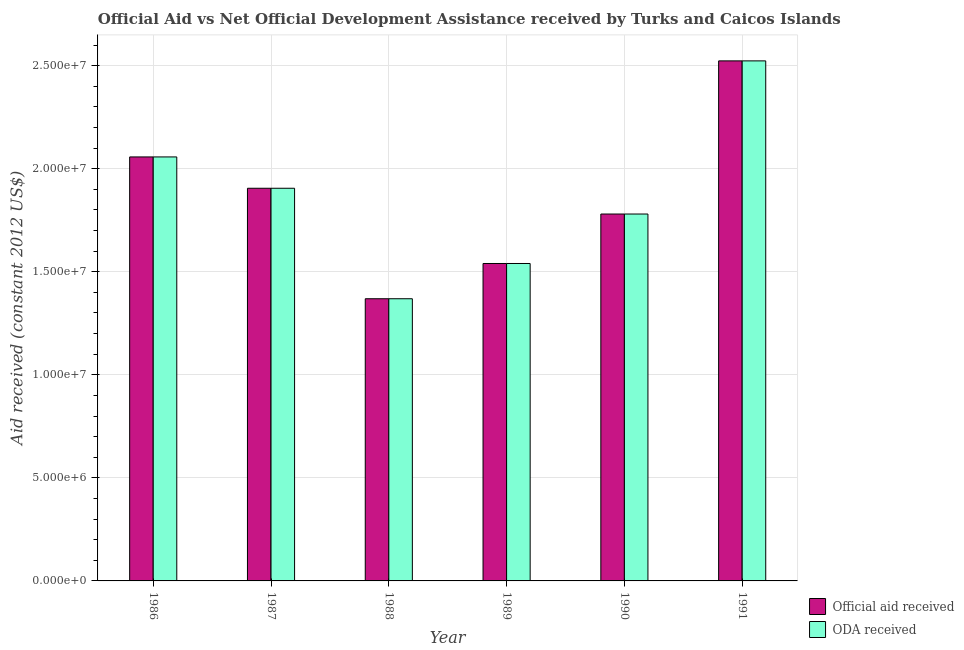Are the number of bars per tick equal to the number of legend labels?
Provide a short and direct response. Yes. How many bars are there on the 1st tick from the left?
Make the answer very short. 2. What is the oda received in 1991?
Provide a succinct answer. 2.52e+07. Across all years, what is the maximum oda received?
Keep it short and to the point. 2.52e+07. Across all years, what is the minimum oda received?
Your response must be concise. 1.37e+07. In which year was the oda received maximum?
Keep it short and to the point. 1991. In which year was the official aid received minimum?
Your answer should be compact. 1988. What is the total official aid received in the graph?
Offer a terse response. 1.12e+08. What is the difference between the official aid received in 1987 and that in 1988?
Offer a very short reply. 5.36e+06. What is the difference between the oda received in 1990 and the official aid received in 1989?
Your answer should be compact. 2.40e+06. What is the average official aid received per year?
Provide a succinct answer. 1.86e+07. In the year 1987, what is the difference between the oda received and official aid received?
Make the answer very short. 0. In how many years, is the official aid received greater than 18000000 US$?
Make the answer very short. 3. What is the ratio of the oda received in 1989 to that in 1990?
Ensure brevity in your answer.  0.87. Is the difference between the oda received in 1989 and 1991 greater than the difference between the official aid received in 1989 and 1991?
Make the answer very short. No. What is the difference between the highest and the second highest official aid received?
Ensure brevity in your answer.  4.66e+06. What is the difference between the highest and the lowest official aid received?
Provide a short and direct response. 1.15e+07. What does the 1st bar from the left in 1990 represents?
Ensure brevity in your answer.  Official aid received. What does the 1st bar from the right in 1989 represents?
Provide a short and direct response. ODA received. How many bars are there?
Your answer should be very brief. 12. Are all the bars in the graph horizontal?
Give a very brief answer. No. Are the values on the major ticks of Y-axis written in scientific E-notation?
Provide a succinct answer. Yes. Does the graph contain any zero values?
Your response must be concise. No. What is the title of the graph?
Provide a succinct answer. Official Aid vs Net Official Development Assistance received by Turks and Caicos Islands . What is the label or title of the Y-axis?
Your answer should be very brief. Aid received (constant 2012 US$). What is the Aid received (constant 2012 US$) in Official aid received in 1986?
Your answer should be compact. 2.06e+07. What is the Aid received (constant 2012 US$) of ODA received in 1986?
Provide a succinct answer. 2.06e+07. What is the Aid received (constant 2012 US$) in Official aid received in 1987?
Your response must be concise. 1.90e+07. What is the Aid received (constant 2012 US$) of ODA received in 1987?
Provide a succinct answer. 1.90e+07. What is the Aid received (constant 2012 US$) in Official aid received in 1988?
Your answer should be compact. 1.37e+07. What is the Aid received (constant 2012 US$) of ODA received in 1988?
Ensure brevity in your answer.  1.37e+07. What is the Aid received (constant 2012 US$) of Official aid received in 1989?
Give a very brief answer. 1.54e+07. What is the Aid received (constant 2012 US$) in ODA received in 1989?
Your answer should be compact. 1.54e+07. What is the Aid received (constant 2012 US$) of Official aid received in 1990?
Make the answer very short. 1.78e+07. What is the Aid received (constant 2012 US$) in ODA received in 1990?
Offer a terse response. 1.78e+07. What is the Aid received (constant 2012 US$) of Official aid received in 1991?
Your response must be concise. 2.52e+07. What is the Aid received (constant 2012 US$) in ODA received in 1991?
Provide a short and direct response. 2.52e+07. Across all years, what is the maximum Aid received (constant 2012 US$) of Official aid received?
Offer a terse response. 2.52e+07. Across all years, what is the maximum Aid received (constant 2012 US$) of ODA received?
Your response must be concise. 2.52e+07. Across all years, what is the minimum Aid received (constant 2012 US$) in Official aid received?
Your answer should be compact. 1.37e+07. Across all years, what is the minimum Aid received (constant 2012 US$) in ODA received?
Your answer should be compact. 1.37e+07. What is the total Aid received (constant 2012 US$) of Official aid received in the graph?
Offer a very short reply. 1.12e+08. What is the total Aid received (constant 2012 US$) in ODA received in the graph?
Ensure brevity in your answer.  1.12e+08. What is the difference between the Aid received (constant 2012 US$) in Official aid received in 1986 and that in 1987?
Offer a very short reply. 1.52e+06. What is the difference between the Aid received (constant 2012 US$) of ODA received in 1986 and that in 1987?
Offer a very short reply. 1.52e+06. What is the difference between the Aid received (constant 2012 US$) of Official aid received in 1986 and that in 1988?
Your answer should be compact. 6.88e+06. What is the difference between the Aid received (constant 2012 US$) of ODA received in 1986 and that in 1988?
Give a very brief answer. 6.88e+06. What is the difference between the Aid received (constant 2012 US$) in Official aid received in 1986 and that in 1989?
Your answer should be compact. 5.17e+06. What is the difference between the Aid received (constant 2012 US$) in ODA received in 1986 and that in 1989?
Keep it short and to the point. 5.17e+06. What is the difference between the Aid received (constant 2012 US$) of Official aid received in 1986 and that in 1990?
Offer a terse response. 2.77e+06. What is the difference between the Aid received (constant 2012 US$) in ODA received in 1986 and that in 1990?
Your response must be concise. 2.77e+06. What is the difference between the Aid received (constant 2012 US$) of Official aid received in 1986 and that in 1991?
Your answer should be very brief. -4.66e+06. What is the difference between the Aid received (constant 2012 US$) of ODA received in 1986 and that in 1991?
Keep it short and to the point. -4.66e+06. What is the difference between the Aid received (constant 2012 US$) of Official aid received in 1987 and that in 1988?
Ensure brevity in your answer.  5.36e+06. What is the difference between the Aid received (constant 2012 US$) of ODA received in 1987 and that in 1988?
Give a very brief answer. 5.36e+06. What is the difference between the Aid received (constant 2012 US$) of Official aid received in 1987 and that in 1989?
Your answer should be compact. 3.65e+06. What is the difference between the Aid received (constant 2012 US$) in ODA received in 1987 and that in 1989?
Keep it short and to the point. 3.65e+06. What is the difference between the Aid received (constant 2012 US$) of Official aid received in 1987 and that in 1990?
Keep it short and to the point. 1.25e+06. What is the difference between the Aid received (constant 2012 US$) of ODA received in 1987 and that in 1990?
Your answer should be very brief. 1.25e+06. What is the difference between the Aid received (constant 2012 US$) in Official aid received in 1987 and that in 1991?
Your response must be concise. -6.18e+06. What is the difference between the Aid received (constant 2012 US$) of ODA received in 1987 and that in 1991?
Your answer should be very brief. -6.18e+06. What is the difference between the Aid received (constant 2012 US$) in Official aid received in 1988 and that in 1989?
Give a very brief answer. -1.71e+06. What is the difference between the Aid received (constant 2012 US$) in ODA received in 1988 and that in 1989?
Provide a short and direct response. -1.71e+06. What is the difference between the Aid received (constant 2012 US$) in Official aid received in 1988 and that in 1990?
Give a very brief answer. -4.11e+06. What is the difference between the Aid received (constant 2012 US$) in ODA received in 1988 and that in 1990?
Your response must be concise. -4.11e+06. What is the difference between the Aid received (constant 2012 US$) in Official aid received in 1988 and that in 1991?
Make the answer very short. -1.15e+07. What is the difference between the Aid received (constant 2012 US$) in ODA received in 1988 and that in 1991?
Provide a short and direct response. -1.15e+07. What is the difference between the Aid received (constant 2012 US$) of Official aid received in 1989 and that in 1990?
Offer a terse response. -2.40e+06. What is the difference between the Aid received (constant 2012 US$) in ODA received in 1989 and that in 1990?
Ensure brevity in your answer.  -2.40e+06. What is the difference between the Aid received (constant 2012 US$) of Official aid received in 1989 and that in 1991?
Ensure brevity in your answer.  -9.83e+06. What is the difference between the Aid received (constant 2012 US$) of ODA received in 1989 and that in 1991?
Offer a terse response. -9.83e+06. What is the difference between the Aid received (constant 2012 US$) in Official aid received in 1990 and that in 1991?
Your answer should be compact. -7.43e+06. What is the difference between the Aid received (constant 2012 US$) of ODA received in 1990 and that in 1991?
Keep it short and to the point. -7.43e+06. What is the difference between the Aid received (constant 2012 US$) of Official aid received in 1986 and the Aid received (constant 2012 US$) of ODA received in 1987?
Offer a terse response. 1.52e+06. What is the difference between the Aid received (constant 2012 US$) of Official aid received in 1986 and the Aid received (constant 2012 US$) of ODA received in 1988?
Your response must be concise. 6.88e+06. What is the difference between the Aid received (constant 2012 US$) in Official aid received in 1986 and the Aid received (constant 2012 US$) in ODA received in 1989?
Provide a succinct answer. 5.17e+06. What is the difference between the Aid received (constant 2012 US$) in Official aid received in 1986 and the Aid received (constant 2012 US$) in ODA received in 1990?
Keep it short and to the point. 2.77e+06. What is the difference between the Aid received (constant 2012 US$) in Official aid received in 1986 and the Aid received (constant 2012 US$) in ODA received in 1991?
Keep it short and to the point. -4.66e+06. What is the difference between the Aid received (constant 2012 US$) of Official aid received in 1987 and the Aid received (constant 2012 US$) of ODA received in 1988?
Provide a short and direct response. 5.36e+06. What is the difference between the Aid received (constant 2012 US$) in Official aid received in 1987 and the Aid received (constant 2012 US$) in ODA received in 1989?
Ensure brevity in your answer.  3.65e+06. What is the difference between the Aid received (constant 2012 US$) in Official aid received in 1987 and the Aid received (constant 2012 US$) in ODA received in 1990?
Provide a short and direct response. 1.25e+06. What is the difference between the Aid received (constant 2012 US$) in Official aid received in 1987 and the Aid received (constant 2012 US$) in ODA received in 1991?
Give a very brief answer. -6.18e+06. What is the difference between the Aid received (constant 2012 US$) in Official aid received in 1988 and the Aid received (constant 2012 US$) in ODA received in 1989?
Offer a very short reply. -1.71e+06. What is the difference between the Aid received (constant 2012 US$) of Official aid received in 1988 and the Aid received (constant 2012 US$) of ODA received in 1990?
Offer a very short reply. -4.11e+06. What is the difference between the Aid received (constant 2012 US$) of Official aid received in 1988 and the Aid received (constant 2012 US$) of ODA received in 1991?
Ensure brevity in your answer.  -1.15e+07. What is the difference between the Aid received (constant 2012 US$) in Official aid received in 1989 and the Aid received (constant 2012 US$) in ODA received in 1990?
Your answer should be very brief. -2.40e+06. What is the difference between the Aid received (constant 2012 US$) of Official aid received in 1989 and the Aid received (constant 2012 US$) of ODA received in 1991?
Your response must be concise. -9.83e+06. What is the difference between the Aid received (constant 2012 US$) of Official aid received in 1990 and the Aid received (constant 2012 US$) of ODA received in 1991?
Offer a terse response. -7.43e+06. What is the average Aid received (constant 2012 US$) in Official aid received per year?
Provide a succinct answer. 1.86e+07. What is the average Aid received (constant 2012 US$) of ODA received per year?
Your answer should be very brief. 1.86e+07. In the year 1986, what is the difference between the Aid received (constant 2012 US$) in Official aid received and Aid received (constant 2012 US$) in ODA received?
Ensure brevity in your answer.  0. In the year 1987, what is the difference between the Aid received (constant 2012 US$) in Official aid received and Aid received (constant 2012 US$) in ODA received?
Give a very brief answer. 0. In the year 1988, what is the difference between the Aid received (constant 2012 US$) in Official aid received and Aid received (constant 2012 US$) in ODA received?
Keep it short and to the point. 0. In the year 1990, what is the difference between the Aid received (constant 2012 US$) in Official aid received and Aid received (constant 2012 US$) in ODA received?
Your answer should be compact. 0. In the year 1991, what is the difference between the Aid received (constant 2012 US$) of Official aid received and Aid received (constant 2012 US$) of ODA received?
Your answer should be very brief. 0. What is the ratio of the Aid received (constant 2012 US$) in Official aid received in 1986 to that in 1987?
Your answer should be very brief. 1.08. What is the ratio of the Aid received (constant 2012 US$) of ODA received in 1986 to that in 1987?
Ensure brevity in your answer.  1.08. What is the ratio of the Aid received (constant 2012 US$) of Official aid received in 1986 to that in 1988?
Your answer should be very brief. 1.5. What is the ratio of the Aid received (constant 2012 US$) of ODA received in 1986 to that in 1988?
Give a very brief answer. 1.5. What is the ratio of the Aid received (constant 2012 US$) in Official aid received in 1986 to that in 1989?
Make the answer very short. 1.34. What is the ratio of the Aid received (constant 2012 US$) in ODA received in 1986 to that in 1989?
Your response must be concise. 1.34. What is the ratio of the Aid received (constant 2012 US$) of Official aid received in 1986 to that in 1990?
Your answer should be very brief. 1.16. What is the ratio of the Aid received (constant 2012 US$) in ODA received in 1986 to that in 1990?
Your answer should be compact. 1.16. What is the ratio of the Aid received (constant 2012 US$) of Official aid received in 1986 to that in 1991?
Your answer should be compact. 0.82. What is the ratio of the Aid received (constant 2012 US$) in ODA received in 1986 to that in 1991?
Your answer should be compact. 0.82. What is the ratio of the Aid received (constant 2012 US$) in Official aid received in 1987 to that in 1988?
Your answer should be compact. 1.39. What is the ratio of the Aid received (constant 2012 US$) in ODA received in 1987 to that in 1988?
Provide a succinct answer. 1.39. What is the ratio of the Aid received (constant 2012 US$) of Official aid received in 1987 to that in 1989?
Provide a short and direct response. 1.24. What is the ratio of the Aid received (constant 2012 US$) in ODA received in 1987 to that in 1989?
Provide a short and direct response. 1.24. What is the ratio of the Aid received (constant 2012 US$) of Official aid received in 1987 to that in 1990?
Your answer should be very brief. 1.07. What is the ratio of the Aid received (constant 2012 US$) in ODA received in 1987 to that in 1990?
Your answer should be compact. 1.07. What is the ratio of the Aid received (constant 2012 US$) in Official aid received in 1987 to that in 1991?
Your response must be concise. 0.76. What is the ratio of the Aid received (constant 2012 US$) of ODA received in 1987 to that in 1991?
Offer a terse response. 0.76. What is the ratio of the Aid received (constant 2012 US$) of Official aid received in 1988 to that in 1989?
Give a very brief answer. 0.89. What is the ratio of the Aid received (constant 2012 US$) of ODA received in 1988 to that in 1989?
Your answer should be compact. 0.89. What is the ratio of the Aid received (constant 2012 US$) of Official aid received in 1988 to that in 1990?
Your answer should be compact. 0.77. What is the ratio of the Aid received (constant 2012 US$) of ODA received in 1988 to that in 1990?
Ensure brevity in your answer.  0.77. What is the ratio of the Aid received (constant 2012 US$) of Official aid received in 1988 to that in 1991?
Offer a terse response. 0.54. What is the ratio of the Aid received (constant 2012 US$) in ODA received in 1988 to that in 1991?
Ensure brevity in your answer.  0.54. What is the ratio of the Aid received (constant 2012 US$) in Official aid received in 1989 to that in 1990?
Provide a short and direct response. 0.87. What is the ratio of the Aid received (constant 2012 US$) of ODA received in 1989 to that in 1990?
Make the answer very short. 0.87. What is the ratio of the Aid received (constant 2012 US$) in Official aid received in 1989 to that in 1991?
Make the answer very short. 0.61. What is the ratio of the Aid received (constant 2012 US$) of ODA received in 1989 to that in 1991?
Your response must be concise. 0.61. What is the ratio of the Aid received (constant 2012 US$) in Official aid received in 1990 to that in 1991?
Offer a terse response. 0.71. What is the ratio of the Aid received (constant 2012 US$) in ODA received in 1990 to that in 1991?
Ensure brevity in your answer.  0.71. What is the difference between the highest and the second highest Aid received (constant 2012 US$) in Official aid received?
Make the answer very short. 4.66e+06. What is the difference between the highest and the second highest Aid received (constant 2012 US$) in ODA received?
Give a very brief answer. 4.66e+06. What is the difference between the highest and the lowest Aid received (constant 2012 US$) of Official aid received?
Offer a very short reply. 1.15e+07. What is the difference between the highest and the lowest Aid received (constant 2012 US$) in ODA received?
Ensure brevity in your answer.  1.15e+07. 